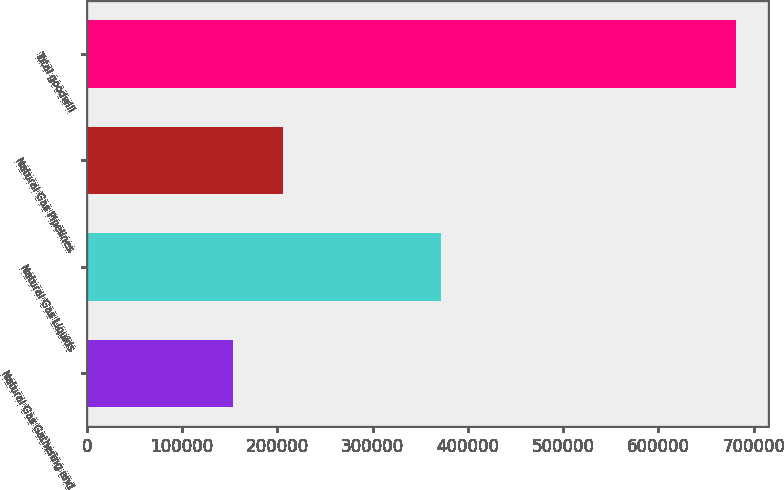Convert chart. <chart><loc_0><loc_0><loc_500><loc_500><bar_chart><fcel>Natural Gas Gathering and<fcel>Natural Gas Liquids<fcel>Natural Gas Pipelines<fcel>Total goodwill<nl><fcel>153404<fcel>371217<fcel>206174<fcel>681100<nl></chart> 